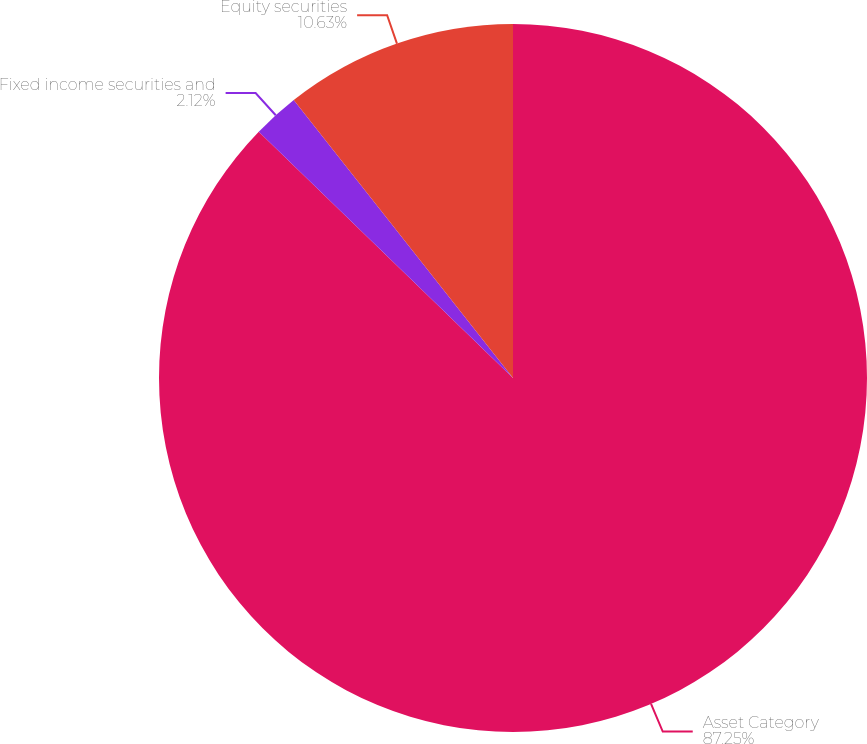<chart> <loc_0><loc_0><loc_500><loc_500><pie_chart><fcel>Asset Category<fcel>Fixed income securities and<fcel>Equity securities<nl><fcel>87.24%<fcel>2.12%<fcel>10.63%<nl></chart> 